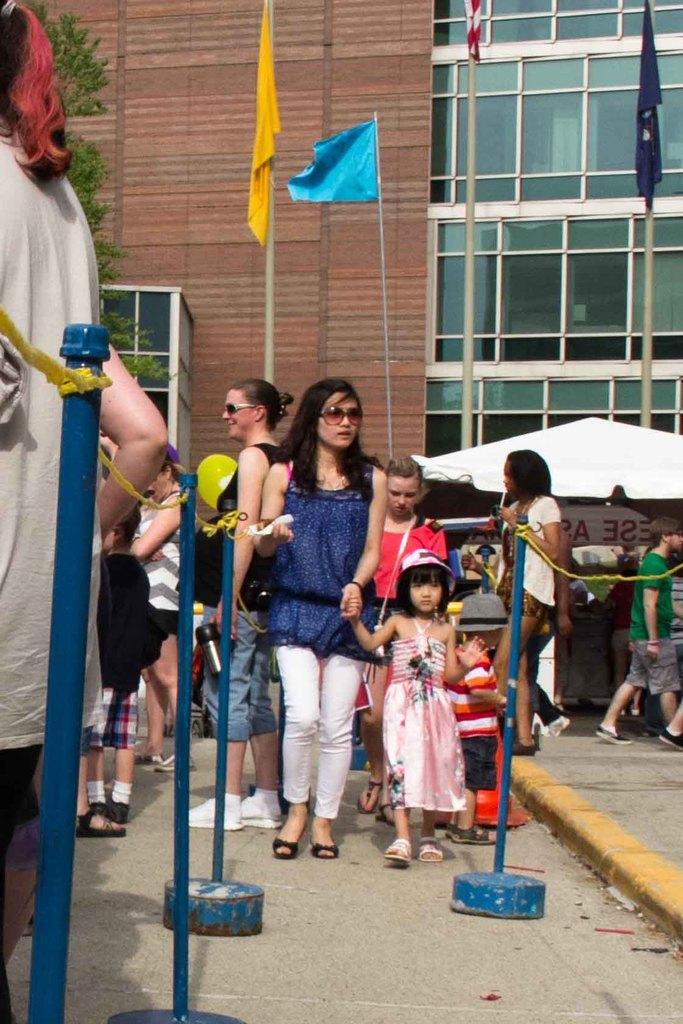Describe this image in one or two sentences. In this image I can see number of persons are standing on the ground. I can see few blue colored pole, few flags which are blue, yellow and red in color, few trees, an umbrella which is white in color and the building. 